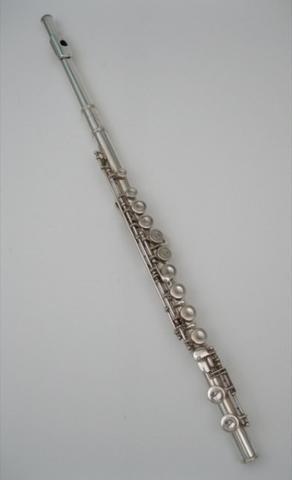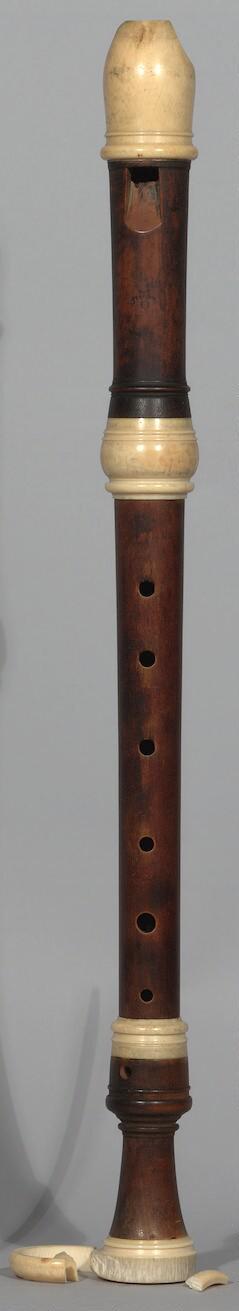The first image is the image on the left, the second image is the image on the right. Evaluate the accuracy of this statement regarding the images: "The instrument on the left is silver and is displayed at an angle, while the instrument on the right is a dark color and is displayed more vertically.". Is it true? Answer yes or no. Yes. The first image is the image on the left, the second image is the image on the right. For the images displayed, is the sentence "One of the instruments is completely silver colored." factually correct? Answer yes or no. Yes. 